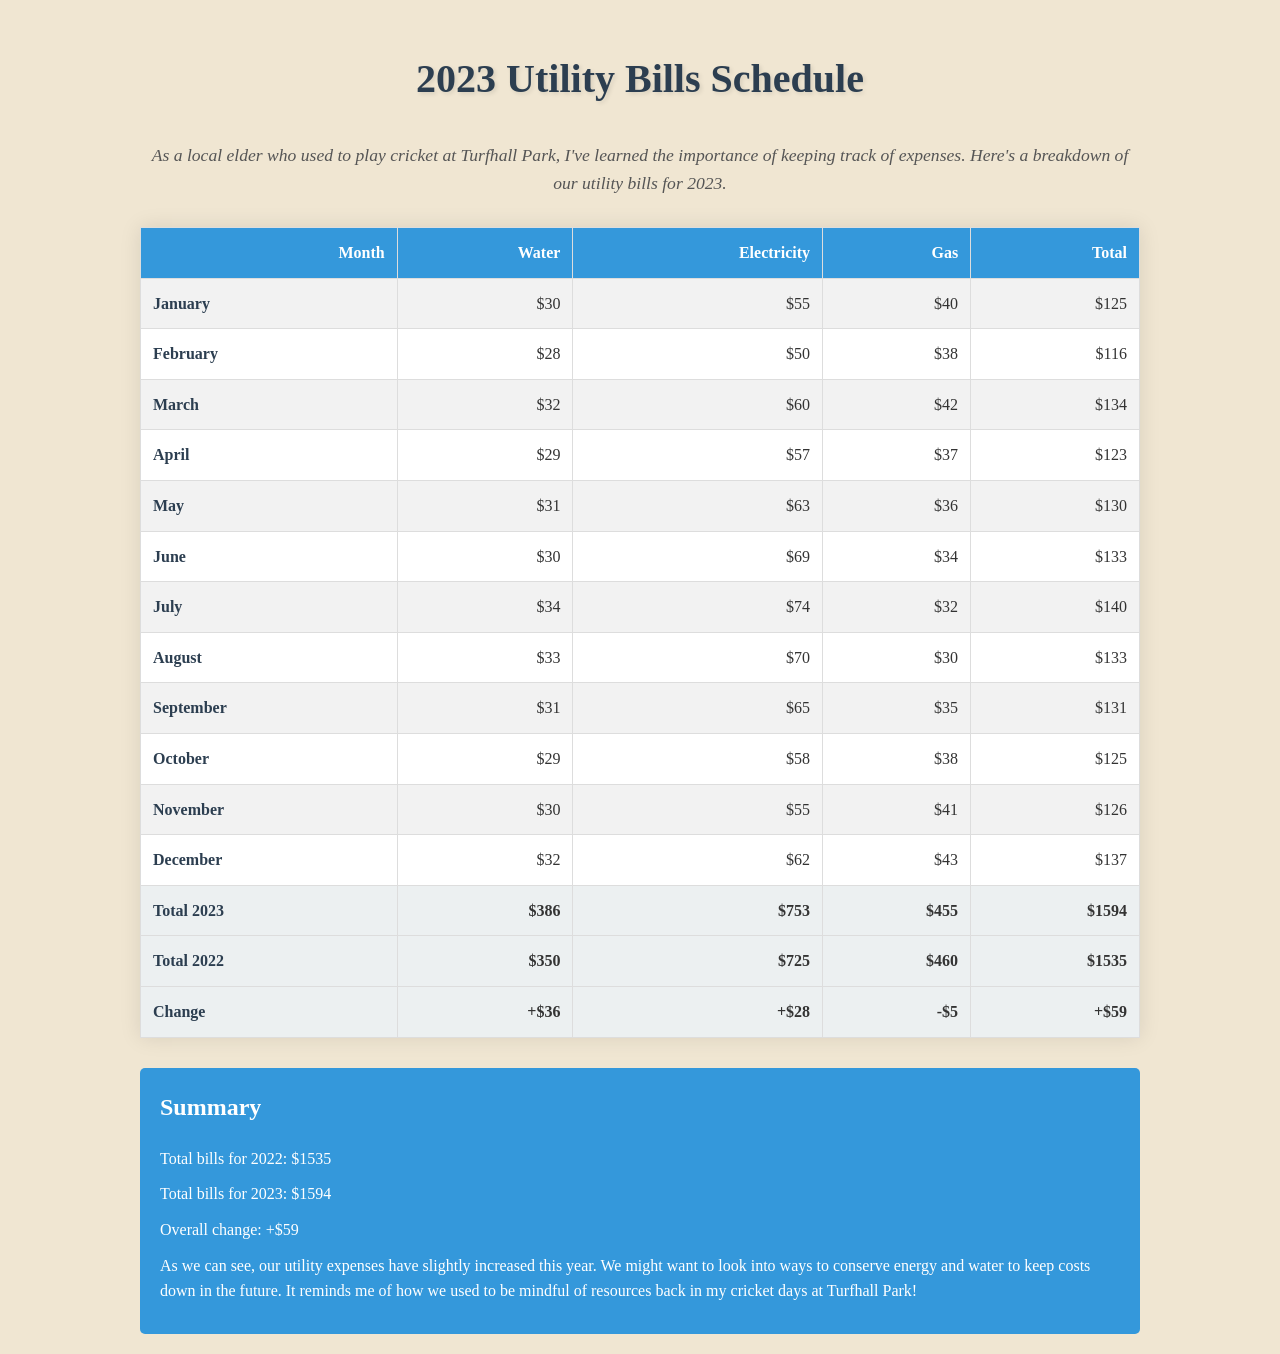What is the total amount spent on water in 2023? The total amount spent on water is the sum of all monthly water charges for 2023, which is $386.
Answer: $386 What was the electricity bill in July? The electricity bill for July is shown in the table for that month, which is $74.
Answer: $74 How much did the gas cost in February? The gas cost for February is listed in the document, which is $38.
Answer: $38 What is the total expense for December 2023? The total expense for December is detailed in the table, which is $137.
Answer: $137 What was the total utility bill change from 2022 to 2023? The change between the total utility bills for both years is calculated in the document, which is +$59.
Answer: +$59 Which utility saw a decrease in expenses from 2022 to 2023? The document states that the gas utility had a decrease of $5 from the previous year.
Answer: Gas What is the total amount spent on utilities in 2022? The total amount for utilities in 2022 is provided in the table, which is $1535.
Answer: $1535 How much more was spent on electricity in 2023 compared to 2022? The increase in electricity spending is calculated by subtracting the 2022 total from the 2023 total, which is $28.
Answer: $28 What month had the highest total utility cost in 2023? By comparing all monthly totals, the month with the highest cost is identified, which is July with $140.
Answer: July 